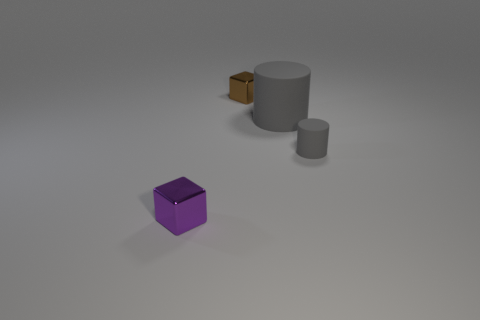Add 2 big gray rubber cylinders. How many objects exist? 6 Subtract all purple blocks. How many blocks are left? 1 Subtract all gray blocks. Subtract all cyan cylinders. How many blocks are left? 2 Subtract all tiny shiny blocks. Subtract all balls. How many objects are left? 2 Add 2 big things. How many big things are left? 3 Add 2 brown metallic cubes. How many brown metallic cubes exist? 3 Subtract 0 cyan cylinders. How many objects are left? 4 